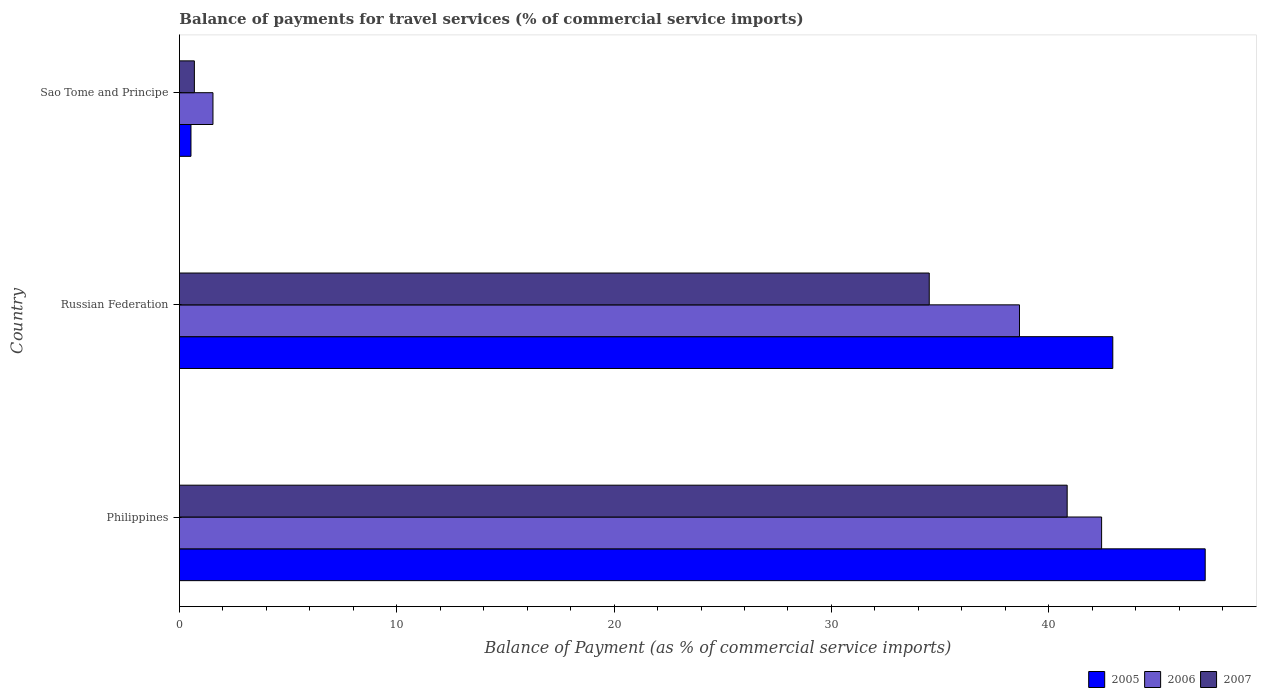What is the label of the 1st group of bars from the top?
Your answer should be compact. Sao Tome and Principe. In how many cases, is the number of bars for a given country not equal to the number of legend labels?
Make the answer very short. 0. What is the balance of payments for travel services in 2006 in Philippines?
Your answer should be very brief. 42.43. Across all countries, what is the maximum balance of payments for travel services in 2007?
Offer a terse response. 40.84. Across all countries, what is the minimum balance of payments for travel services in 2006?
Keep it short and to the point. 1.54. In which country was the balance of payments for travel services in 2005 maximum?
Offer a terse response. Philippines. In which country was the balance of payments for travel services in 2006 minimum?
Provide a succinct answer. Sao Tome and Principe. What is the total balance of payments for travel services in 2007 in the graph?
Ensure brevity in your answer.  76.03. What is the difference between the balance of payments for travel services in 2006 in Philippines and that in Russian Federation?
Your response must be concise. 3.78. What is the difference between the balance of payments for travel services in 2006 in Philippines and the balance of payments for travel services in 2007 in Sao Tome and Principe?
Your response must be concise. 41.74. What is the average balance of payments for travel services in 2006 per country?
Give a very brief answer. 27.54. What is the difference between the balance of payments for travel services in 2007 and balance of payments for travel services in 2005 in Russian Federation?
Make the answer very short. -8.44. In how many countries, is the balance of payments for travel services in 2006 greater than 18 %?
Give a very brief answer. 2. What is the ratio of the balance of payments for travel services in 2007 in Philippines to that in Russian Federation?
Your answer should be compact. 1.18. What is the difference between the highest and the second highest balance of payments for travel services in 2006?
Keep it short and to the point. 3.78. What is the difference between the highest and the lowest balance of payments for travel services in 2005?
Offer a very short reply. 46.66. In how many countries, is the balance of payments for travel services in 2006 greater than the average balance of payments for travel services in 2006 taken over all countries?
Provide a succinct answer. 2. How many bars are there?
Ensure brevity in your answer.  9. How many countries are there in the graph?
Your answer should be very brief. 3. How are the legend labels stacked?
Give a very brief answer. Horizontal. What is the title of the graph?
Make the answer very short. Balance of payments for travel services (% of commercial service imports). What is the label or title of the X-axis?
Provide a short and direct response. Balance of Payment (as % of commercial service imports). What is the Balance of Payment (as % of commercial service imports) in 2005 in Philippines?
Your response must be concise. 47.2. What is the Balance of Payment (as % of commercial service imports) in 2006 in Philippines?
Provide a short and direct response. 42.43. What is the Balance of Payment (as % of commercial service imports) in 2007 in Philippines?
Ensure brevity in your answer.  40.84. What is the Balance of Payment (as % of commercial service imports) in 2005 in Russian Federation?
Offer a terse response. 42.94. What is the Balance of Payment (as % of commercial service imports) of 2006 in Russian Federation?
Offer a terse response. 38.65. What is the Balance of Payment (as % of commercial service imports) of 2007 in Russian Federation?
Provide a succinct answer. 34.5. What is the Balance of Payment (as % of commercial service imports) of 2005 in Sao Tome and Principe?
Offer a very short reply. 0.53. What is the Balance of Payment (as % of commercial service imports) of 2006 in Sao Tome and Principe?
Provide a short and direct response. 1.54. What is the Balance of Payment (as % of commercial service imports) of 2007 in Sao Tome and Principe?
Offer a terse response. 0.69. Across all countries, what is the maximum Balance of Payment (as % of commercial service imports) of 2005?
Your answer should be very brief. 47.2. Across all countries, what is the maximum Balance of Payment (as % of commercial service imports) of 2006?
Ensure brevity in your answer.  42.43. Across all countries, what is the maximum Balance of Payment (as % of commercial service imports) in 2007?
Offer a terse response. 40.84. Across all countries, what is the minimum Balance of Payment (as % of commercial service imports) in 2005?
Your answer should be compact. 0.53. Across all countries, what is the minimum Balance of Payment (as % of commercial service imports) of 2006?
Offer a very short reply. 1.54. Across all countries, what is the minimum Balance of Payment (as % of commercial service imports) of 2007?
Ensure brevity in your answer.  0.69. What is the total Balance of Payment (as % of commercial service imports) in 2005 in the graph?
Give a very brief answer. 90.67. What is the total Balance of Payment (as % of commercial service imports) in 2006 in the graph?
Keep it short and to the point. 82.62. What is the total Balance of Payment (as % of commercial service imports) of 2007 in the graph?
Offer a very short reply. 76.03. What is the difference between the Balance of Payment (as % of commercial service imports) in 2005 in Philippines and that in Russian Federation?
Make the answer very short. 4.25. What is the difference between the Balance of Payment (as % of commercial service imports) of 2006 in Philippines and that in Russian Federation?
Offer a very short reply. 3.78. What is the difference between the Balance of Payment (as % of commercial service imports) of 2007 in Philippines and that in Russian Federation?
Ensure brevity in your answer.  6.35. What is the difference between the Balance of Payment (as % of commercial service imports) of 2005 in Philippines and that in Sao Tome and Principe?
Ensure brevity in your answer.  46.66. What is the difference between the Balance of Payment (as % of commercial service imports) in 2006 in Philippines and that in Sao Tome and Principe?
Make the answer very short. 40.89. What is the difference between the Balance of Payment (as % of commercial service imports) in 2007 in Philippines and that in Sao Tome and Principe?
Ensure brevity in your answer.  40.16. What is the difference between the Balance of Payment (as % of commercial service imports) in 2005 in Russian Federation and that in Sao Tome and Principe?
Provide a short and direct response. 42.41. What is the difference between the Balance of Payment (as % of commercial service imports) in 2006 in Russian Federation and that in Sao Tome and Principe?
Your answer should be compact. 37.11. What is the difference between the Balance of Payment (as % of commercial service imports) in 2007 in Russian Federation and that in Sao Tome and Principe?
Offer a very short reply. 33.81. What is the difference between the Balance of Payment (as % of commercial service imports) of 2005 in Philippines and the Balance of Payment (as % of commercial service imports) of 2006 in Russian Federation?
Keep it short and to the point. 8.54. What is the difference between the Balance of Payment (as % of commercial service imports) of 2005 in Philippines and the Balance of Payment (as % of commercial service imports) of 2007 in Russian Federation?
Provide a short and direct response. 12.7. What is the difference between the Balance of Payment (as % of commercial service imports) of 2006 in Philippines and the Balance of Payment (as % of commercial service imports) of 2007 in Russian Federation?
Make the answer very short. 7.93. What is the difference between the Balance of Payment (as % of commercial service imports) in 2005 in Philippines and the Balance of Payment (as % of commercial service imports) in 2006 in Sao Tome and Principe?
Offer a terse response. 45.65. What is the difference between the Balance of Payment (as % of commercial service imports) in 2005 in Philippines and the Balance of Payment (as % of commercial service imports) in 2007 in Sao Tome and Principe?
Provide a short and direct response. 46.51. What is the difference between the Balance of Payment (as % of commercial service imports) of 2006 in Philippines and the Balance of Payment (as % of commercial service imports) of 2007 in Sao Tome and Principe?
Your response must be concise. 41.74. What is the difference between the Balance of Payment (as % of commercial service imports) in 2005 in Russian Federation and the Balance of Payment (as % of commercial service imports) in 2006 in Sao Tome and Principe?
Ensure brevity in your answer.  41.4. What is the difference between the Balance of Payment (as % of commercial service imports) of 2005 in Russian Federation and the Balance of Payment (as % of commercial service imports) of 2007 in Sao Tome and Principe?
Ensure brevity in your answer.  42.26. What is the difference between the Balance of Payment (as % of commercial service imports) of 2006 in Russian Federation and the Balance of Payment (as % of commercial service imports) of 2007 in Sao Tome and Principe?
Provide a short and direct response. 37.96. What is the average Balance of Payment (as % of commercial service imports) of 2005 per country?
Give a very brief answer. 30.22. What is the average Balance of Payment (as % of commercial service imports) in 2006 per country?
Give a very brief answer. 27.54. What is the average Balance of Payment (as % of commercial service imports) of 2007 per country?
Offer a terse response. 25.34. What is the difference between the Balance of Payment (as % of commercial service imports) in 2005 and Balance of Payment (as % of commercial service imports) in 2006 in Philippines?
Make the answer very short. 4.77. What is the difference between the Balance of Payment (as % of commercial service imports) of 2005 and Balance of Payment (as % of commercial service imports) of 2007 in Philippines?
Offer a terse response. 6.35. What is the difference between the Balance of Payment (as % of commercial service imports) in 2006 and Balance of Payment (as % of commercial service imports) in 2007 in Philippines?
Provide a succinct answer. 1.58. What is the difference between the Balance of Payment (as % of commercial service imports) in 2005 and Balance of Payment (as % of commercial service imports) in 2006 in Russian Federation?
Your answer should be compact. 4.29. What is the difference between the Balance of Payment (as % of commercial service imports) of 2005 and Balance of Payment (as % of commercial service imports) of 2007 in Russian Federation?
Keep it short and to the point. 8.44. What is the difference between the Balance of Payment (as % of commercial service imports) of 2006 and Balance of Payment (as % of commercial service imports) of 2007 in Russian Federation?
Provide a short and direct response. 4.15. What is the difference between the Balance of Payment (as % of commercial service imports) of 2005 and Balance of Payment (as % of commercial service imports) of 2006 in Sao Tome and Principe?
Give a very brief answer. -1.01. What is the difference between the Balance of Payment (as % of commercial service imports) in 2005 and Balance of Payment (as % of commercial service imports) in 2007 in Sao Tome and Principe?
Offer a very short reply. -0.16. What is the difference between the Balance of Payment (as % of commercial service imports) of 2006 and Balance of Payment (as % of commercial service imports) of 2007 in Sao Tome and Principe?
Provide a short and direct response. 0.86. What is the ratio of the Balance of Payment (as % of commercial service imports) in 2005 in Philippines to that in Russian Federation?
Offer a very short reply. 1.1. What is the ratio of the Balance of Payment (as % of commercial service imports) of 2006 in Philippines to that in Russian Federation?
Give a very brief answer. 1.1. What is the ratio of the Balance of Payment (as % of commercial service imports) in 2007 in Philippines to that in Russian Federation?
Your answer should be compact. 1.18. What is the ratio of the Balance of Payment (as % of commercial service imports) of 2005 in Philippines to that in Sao Tome and Principe?
Provide a short and direct response. 88.75. What is the ratio of the Balance of Payment (as % of commercial service imports) of 2006 in Philippines to that in Sao Tome and Principe?
Provide a short and direct response. 27.49. What is the ratio of the Balance of Payment (as % of commercial service imports) of 2007 in Philippines to that in Sao Tome and Principe?
Make the answer very short. 59.35. What is the ratio of the Balance of Payment (as % of commercial service imports) in 2005 in Russian Federation to that in Sao Tome and Principe?
Keep it short and to the point. 80.75. What is the ratio of the Balance of Payment (as % of commercial service imports) of 2006 in Russian Federation to that in Sao Tome and Principe?
Ensure brevity in your answer.  25.04. What is the ratio of the Balance of Payment (as % of commercial service imports) in 2007 in Russian Federation to that in Sao Tome and Principe?
Your response must be concise. 50.13. What is the difference between the highest and the second highest Balance of Payment (as % of commercial service imports) in 2005?
Your response must be concise. 4.25. What is the difference between the highest and the second highest Balance of Payment (as % of commercial service imports) in 2006?
Provide a short and direct response. 3.78. What is the difference between the highest and the second highest Balance of Payment (as % of commercial service imports) in 2007?
Provide a short and direct response. 6.35. What is the difference between the highest and the lowest Balance of Payment (as % of commercial service imports) of 2005?
Offer a very short reply. 46.66. What is the difference between the highest and the lowest Balance of Payment (as % of commercial service imports) of 2006?
Offer a very short reply. 40.89. What is the difference between the highest and the lowest Balance of Payment (as % of commercial service imports) of 2007?
Give a very brief answer. 40.16. 